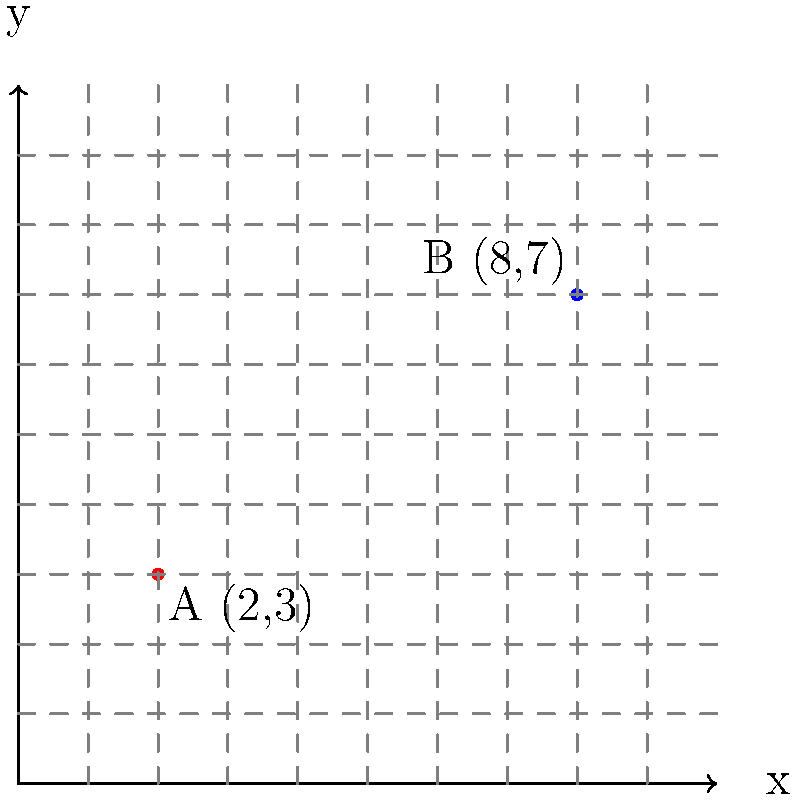At the Warsaw Grand Theatre, two renowned Polish coloratura sopranos, Ewa and Maria, are seated in the VIP area. On the seating chart represented by a coordinate plane, Ewa's seat is at point A (2,3) and Maria's seat is at point B (8,7). What is the straight-line distance between their seats, rounded to the nearest tenth of a unit? To find the distance between two points on a coordinate plane, we can use the distance formula:

$$d = \sqrt{(x_2-x_1)^2 + (y_2-y_1)^2}$$

Where $(x_1,y_1)$ is the coordinate of the first point and $(x_2,y_2)$ is the coordinate of the second point.

Let's plug in the values:
- Point A (Ewa's seat): $(x_1,y_1) = (2,3)$
- Point B (Maria's seat): $(x_2,y_2) = (8,7)$

Now, let's calculate:

$$\begin{align}
d &= \sqrt{(8-2)^2 + (7-3)^2} \\
&= \sqrt{6^2 + 4^2} \\
&= \sqrt{36 + 16} \\
&= \sqrt{52} \\
&\approx 7.21
\end{align}$$

Rounding to the nearest tenth, we get 7.2 units.
Answer: 7.2 units 